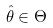Convert formula to latex. <formula><loc_0><loc_0><loc_500><loc_500>\hat { \theta } \in \Theta</formula> 